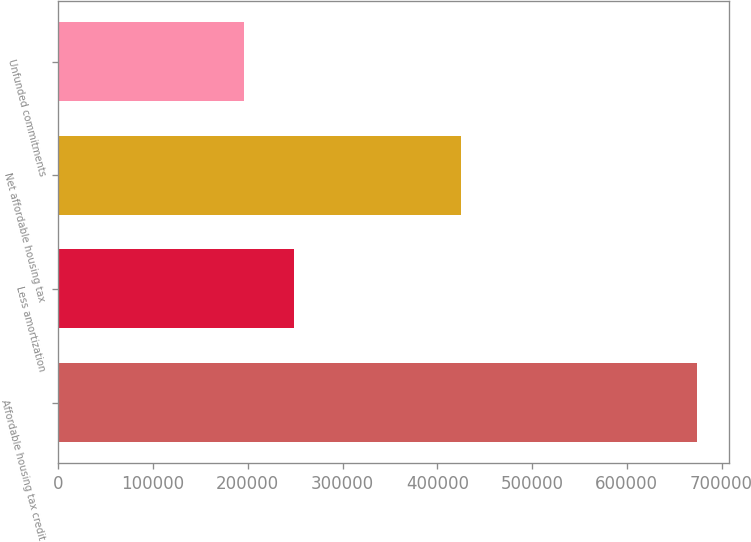Convert chart. <chart><loc_0><loc_0><loc_500><loc_500><bar_chart><fcel>Affordable housing tax credit<fcel>Less amortization<fcel>Net affordable housing tax<fcel>Unfunded commitments<nl><fcel>674157<fcel>248657<fcel>425500<fcel>196001<nl></chart> 